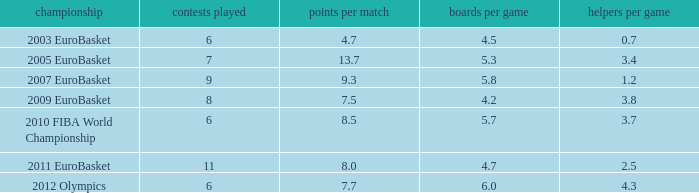How many points per game have the tournament 2005 eurobasket? 13.7. 